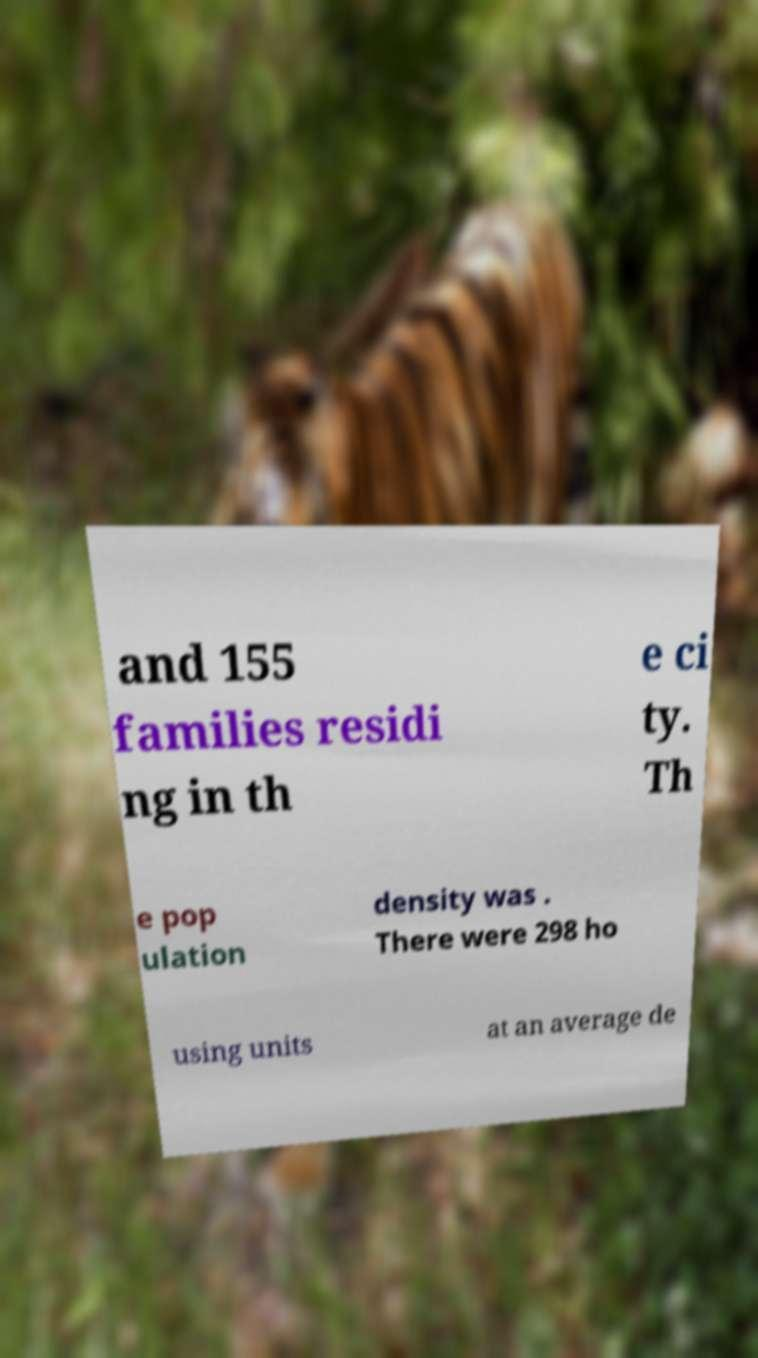Could you assist in decoding the text presented in this image and type it out clearly? and 155 families residi ng in th e ci ty. Th e pop ulation density was . There were 298 ho using units at an average de 